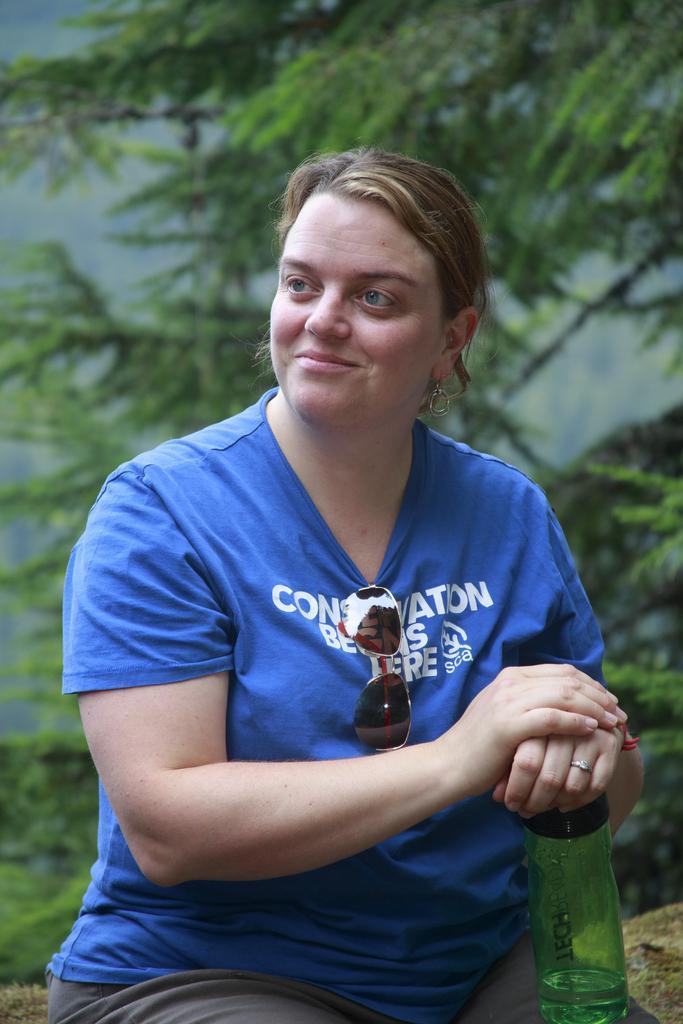How would you summarize this image in a sentence or two? This picture shows a woman seated with a smile on her face, and she holds a water bottle in her hand and we see a tree back of her. 